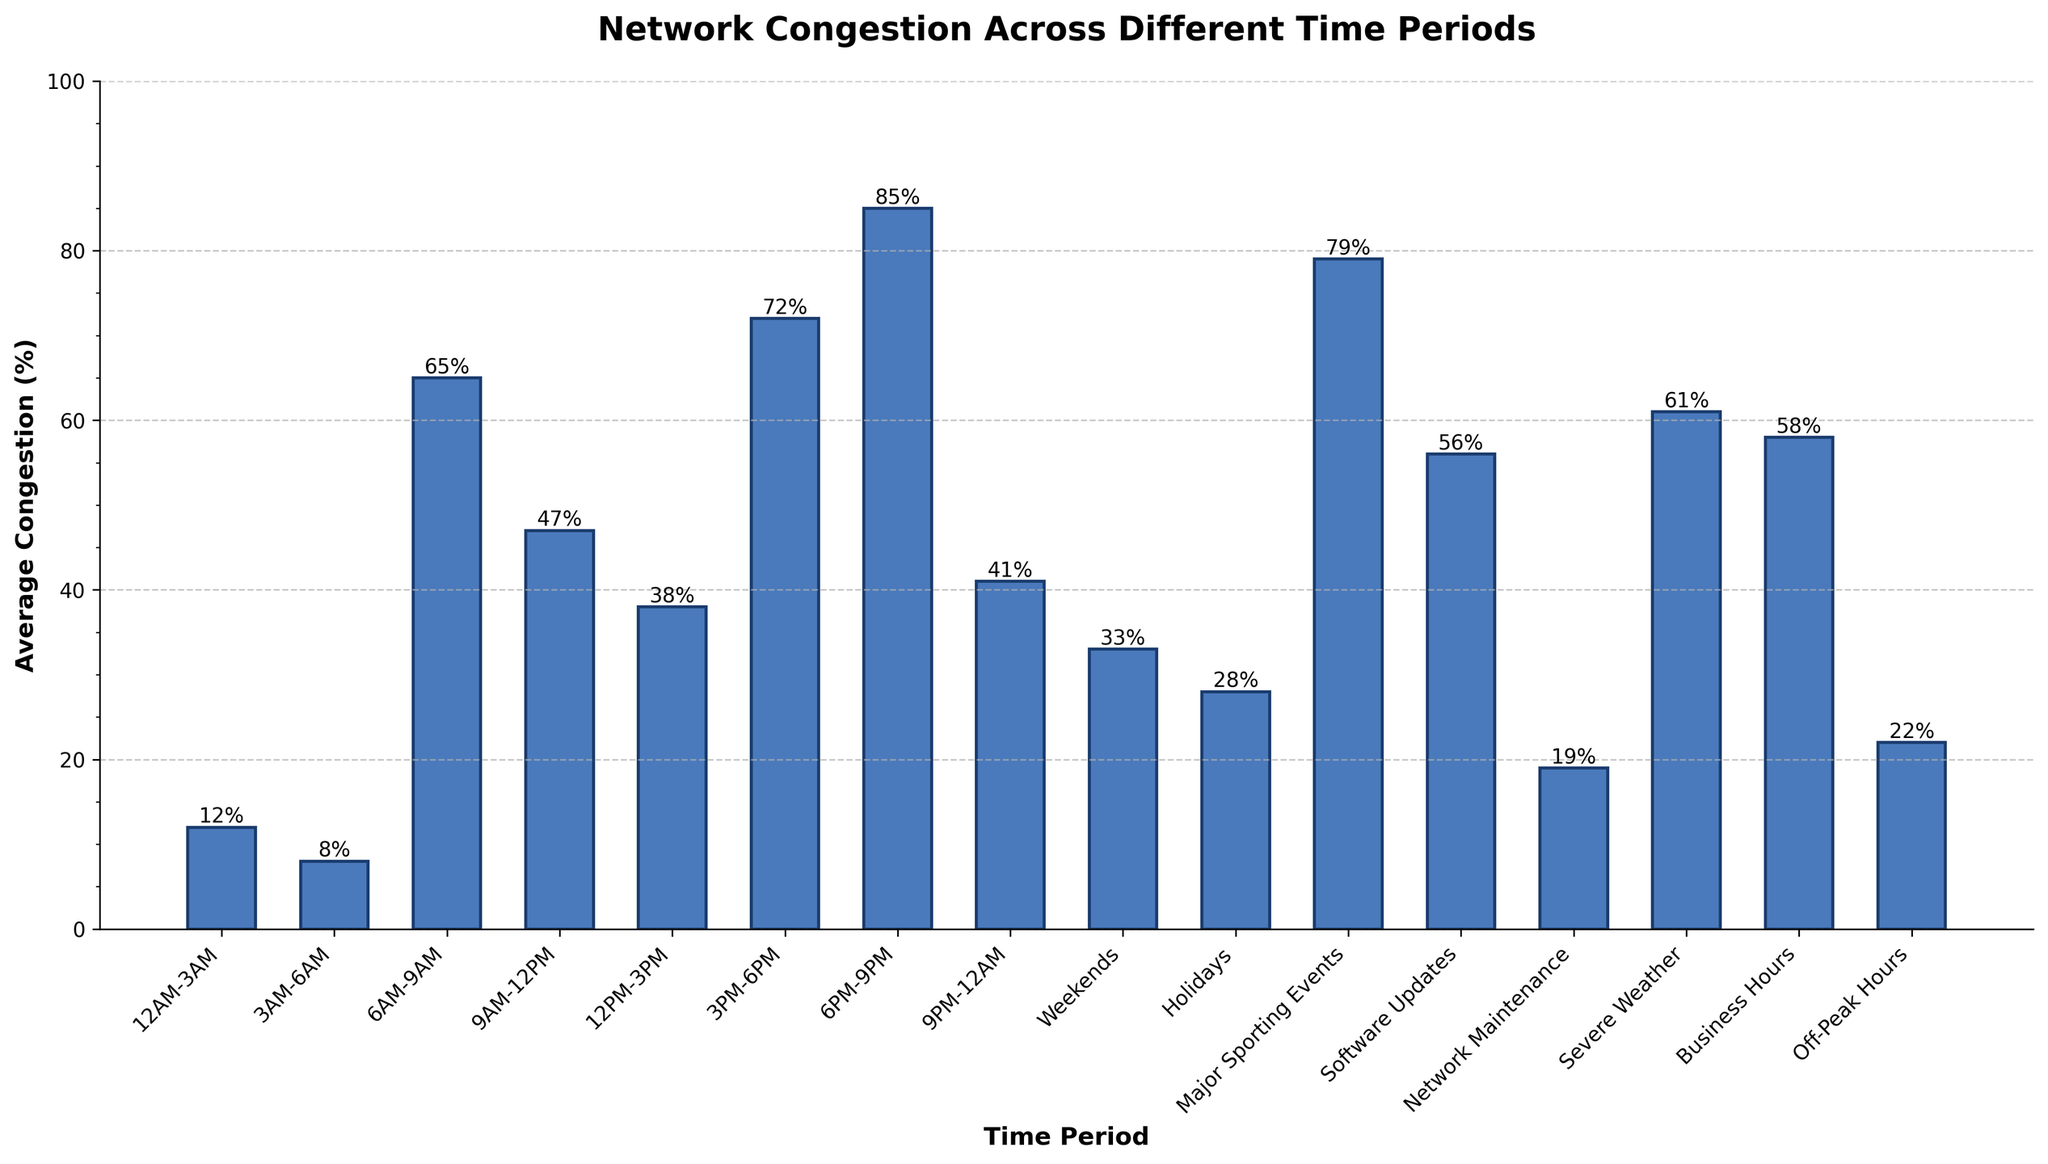What time period has the highest average network congestion? Look at the top of each bar to identify the highest bar in the chart. The bar corresponding to 6PM-9PM is the tallest.
Answer: 6PM-9PM What is the average congestion during peak hours (6AM-9AM, 3PM-6PM, 6PM-9PM)? Sum the average congestion for the peak hours (65% + 72% + 85%) and divide by the number of peak hours (3). The calculation is (65 + 72 + 85) / 3.
Answer: 74% How much greater is the congestion during major sporting events compared to holidays? Subtract the average congestion during holidays (28%) from that during major sporting events (79%). The calculation is 79 - 28.
Answer: 51% Which time period has lower congestion: Business Hours or Severe Weather? Compare the average congestion during Business Hours (58%) to that during Severe Weather (61%). The value for Business Hours is smaller.
Answer: Business Hours What is the total congestion percentage for Software Updates and Network Maintenance? Add the average congestion for Software Updates (56%) to Network Maintenance (19%). The calculation is 56 + 19.
Answer: 75% Which is the least congested time period? Identify the shortest bar in the chart. The bar corresponding to 3AM-6AM is the shortest.
Answer: 3AM-6AM By how much does the congestion during 9AM-12PM exceed that during Off-Peak Hours? Subtract the average congestion during Off-Peak Hours (22%) from that during 9AM-12PM (47%). The calculation is 47 - 22.
Answer: 25% What is the difference in congestion between 12PM-3PM and Weekends? Subtract the average congestion during Weekends (33%) from that during 12PM-3PM (38%). The calculation is 38 - 33.
Answer: 5% Compare the average congestion between Network Maintenance and Off-Peak Hours. Which one is higher and by how much? Subtract the average congestion during Off-Peak Hours (22%) from Network Maintenance (19%). Since 19% is lower, the difference is 22 - 19.
Answer: Off-Peak Hours by 3% 